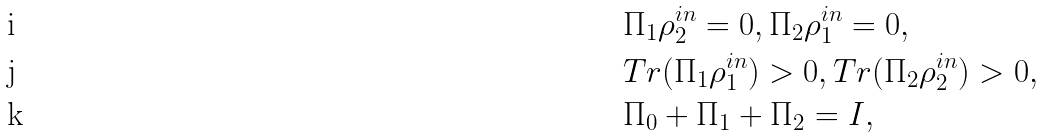Convert formula to latex. <formula><loc_0><loc_0><loc_500><loc_500>& \Pi _ { 1 } \rho ^ { i n } _ { 2 } = 0 , \Pi _ { 2 } \rho ^ { i n } _ { 1 } = 0 , \\ & T r ( \Pi _ { 1 } \rho ^ { i n } _ { 1 } ) > 0 , T r ( \Pi _ { 2 } \rho ^ { i n } _ { 2 } ) > 0 , \\ & \Pi _ { 0 } + \Pi _ { 1 } + \Pi _ { 2 } = I ,</formula> 